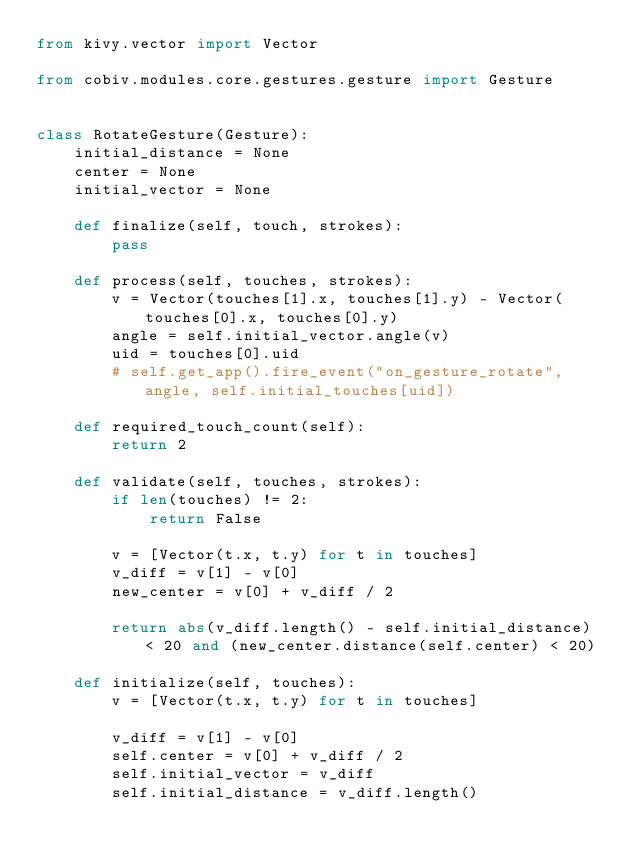<code> <loc_0><loc_0><loc_500><loc_500><_Python_>from kivy.vector import Vector

from cobiv.modules.core.gestures.gesture import Gesture


class RotateGesture(Gesture):
    initial_distance = None
    center = None
    initial_vector = None

    def finalize(self, touch, strokes):
        pass

    def process(self, touches, strokes):
        v = Vector(touches[1].x, touches[1].y) - Vector(touches[0].x, touches[0].y)
        angle = self.initial_vector.angle(v)
        uid = touches[0].uid
        # self.get_app().fire_event("on_gesture_rotate", angle, self.initial_touches[uid])

    def required_touch_count(self):
        return 2

    def validate(self, touches, strokes):
        if len(touches) != 2:
            return False

        v = [Vector(t.x, t.y) for t in touches]
        v_diff = v[1] - v[0]
        new_center = v[0] + v_diff / 2

        return abs(v_diff.length() - self.initial_distance) < 20 and (new_center.distance(self.center) < 20)

    def initialize(self, touches):
        v = [Vector(t.x, t.y) for t in touches]

        v_diff = v[1] - v[0]
        self.center = v[0] + v_diff / 2
        self.initial_vector = v_diff
        self.initial_distance = v_diff.length()
</code> 